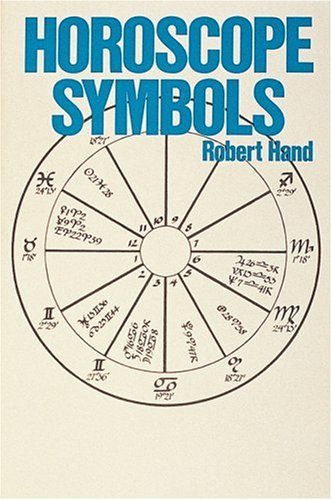What can readers expect to learn from this book? Readers can delve into the meanings behind different horoscope symbols used in astrology, learning how these symbols influence personality analysis and forecasting in astrological practices. How detailed is the information presented? The book provides comprehensive details on each symbol, including their historical origins, practical applications in astrological charts, and their interactions with other astrological elements. 